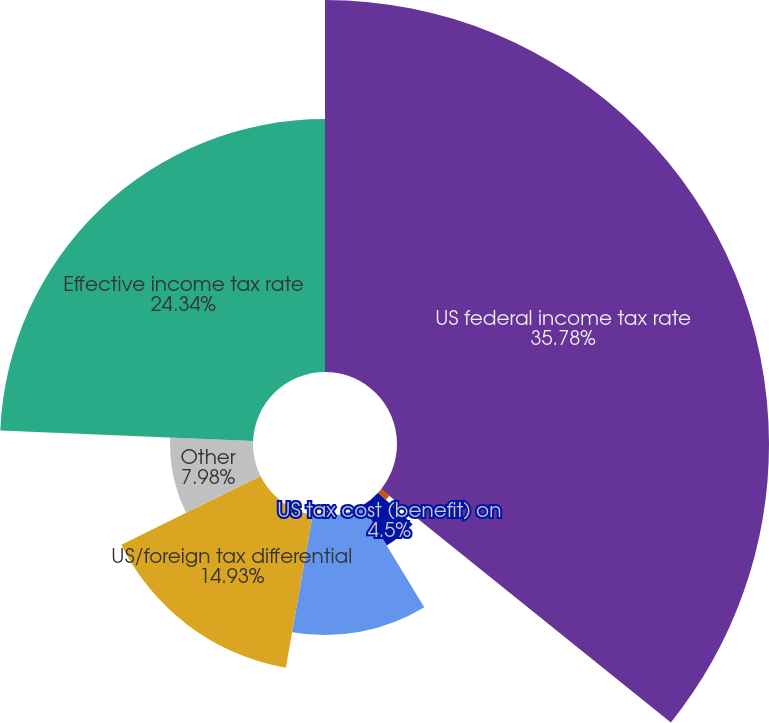Convert chart to OTSL. <chart><loc_0><loc_0><loc_500><loc_500><pie_chart><fcel>US federal income tax rate<fcel>US state and local taxes<fcel>US tax cost (benefit) on<fcel>US tax incentives<fcel>US/foreign tax differential<fcel>Other<fcel>Effective income tax rate<nl><fcel>35.79%<fcel>1.02%<fcel>4.5%<fcel>11.45%<fcel>14.93%<fcel>7.98%<fcel>24.34%<nl></chart> 